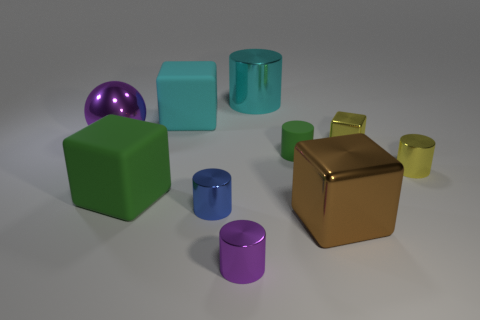Subtract all blue cylinders. How many cylinders are left? 4 Subtract all yellow cylinders. How many cylinders are left? 4 Subtract all cubes. How many objects are left? 6 Subtract 2 cubes. How many cubes are left? 2 Subtract all yellow cylinders. How many blue spheres are left? 0 Subtract all brown cubes. Subtract all large cyan matte cubes. How many objects are left? 8 Add 2 cyan metal objects. How many cyan metal objects are left? 3 Add 2 big cyan cylinders. How many big cyan cylinders exist? 3 Subtract 0 red balls. How many objects are left? 10 Subtract all cyan cubes. Subtract all blue balls. How many cubes are left? 3 